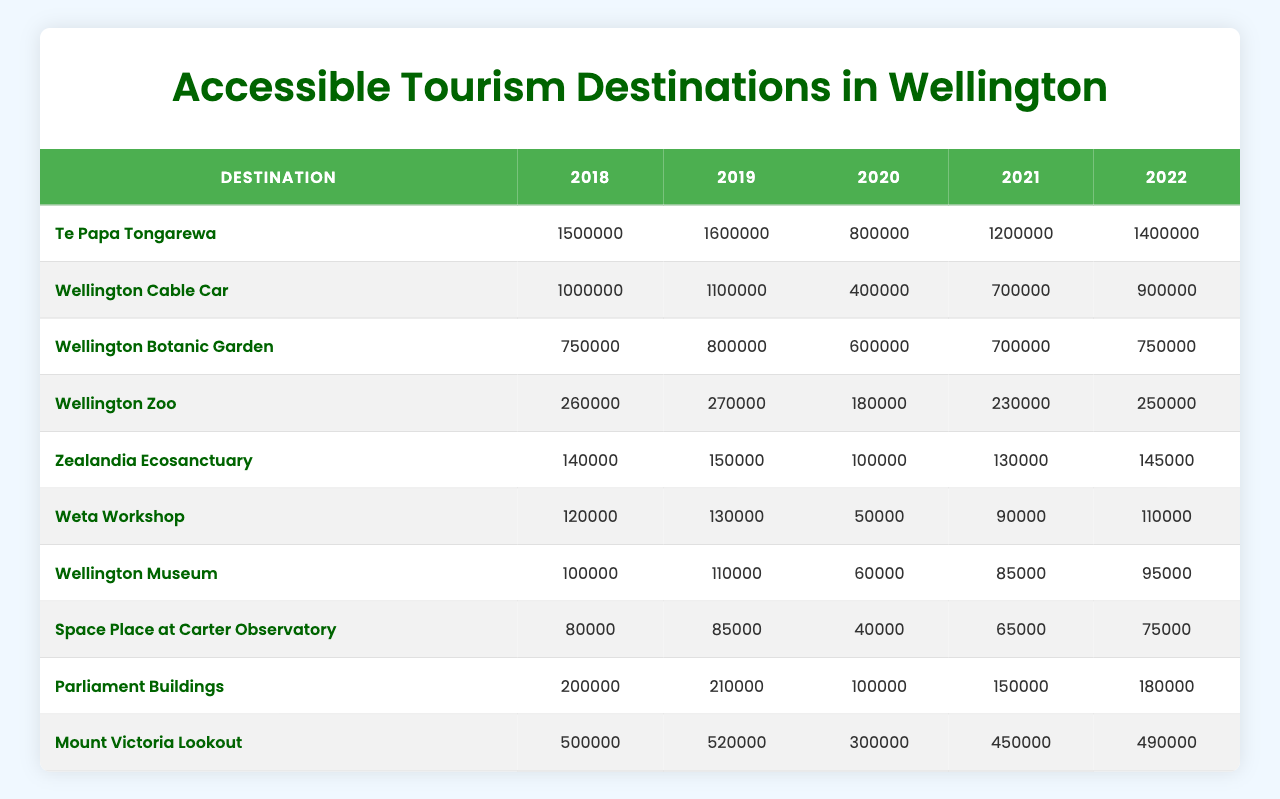What was the visitor number for Wellington Zoo in 2020? Referring to the table, the entry for Wellington Zoo in the year 2020 shows a visitor number of 180,000.
Answer: 180000 Which destination had the highest number of visitors in 2019? Looking at the table for the year 2019, Te Papa Tongarewa had the highest visitor count at 1,600,000 compared to other destinations.
Answer: Te Papa Tongarewa What is the total number of visitors to Zealandia Ecosanctuary from 2018 to 2022? Summing the visitor numbers from 2018 (140,000), 2019 (150,000), 2020 (100,000), 2021 (130,000), and 2022 (145,000) gives 140,000 + 150,000 + 100,000 + 130,000 + 145,000 = 665,000.
Answer: 665000 Did the visitor numbers for Mount Victoria Lookout increase from 2021 to 2022? Checking the numbers, Mount Victoria Lookout had 450,000 visitors in 2021 and 490,000 in 2022, indicating an increase.
Answer: Yes What was the average number of visitors to Wellington Museum from 2018 to 2022? The visitor counts for Wellington Museum are 100,000 (2018), 110,000 (2019), 60,000 (2020), 85,000 (2021), and 95,000 (2022). The total is 100,000 + 110,000 + 60,000 + 85,000 + 95,000 = 450,000, and dividing by 5 gives an average of 90,000.
Answer: 90000 Which destination recorded a visitor number of 50,000 in 2020? The table shows that Weta Workshop had 50,000 visitors in 2020, which is the only destination with that count.
Answer: Weta Workshop What is the difference in visitor numbers for the Wellington Cable Car between 2018 and 2022? For Wellington Cable Car, the visitor numbers were 1,000,000 in 2018 and 900,000 in 2022. The difference is 1,000,000 - 900,000 = 100,000.
Answer: 100000 Was the visitor number for the Wellington Botanic Garden less than 800,000 in 2020? In 2020, the table indicates that Wellington Botanic Garden had 600,000 visitors, which is indeed less than 800,000.
Answer: Yes By what percentage did the visitor numbers for Te Papa Tongarewa decrease from 2019 to 2020? The visitor numbers were 1,600,000 in 2019 and 800,000 in 2020. The decrease is 1,600,000 - 800,000 = 800,000. The percentage decrease is (800,000 / 1,600,000) * 100 = 50%.
Answer: 50% Which destination had the lowest number of visitors in 2021? According to the visitor counts in 2021, Wellington Museum had the lowest number of visitors at 85,000.
Answer: Wellington Museum 